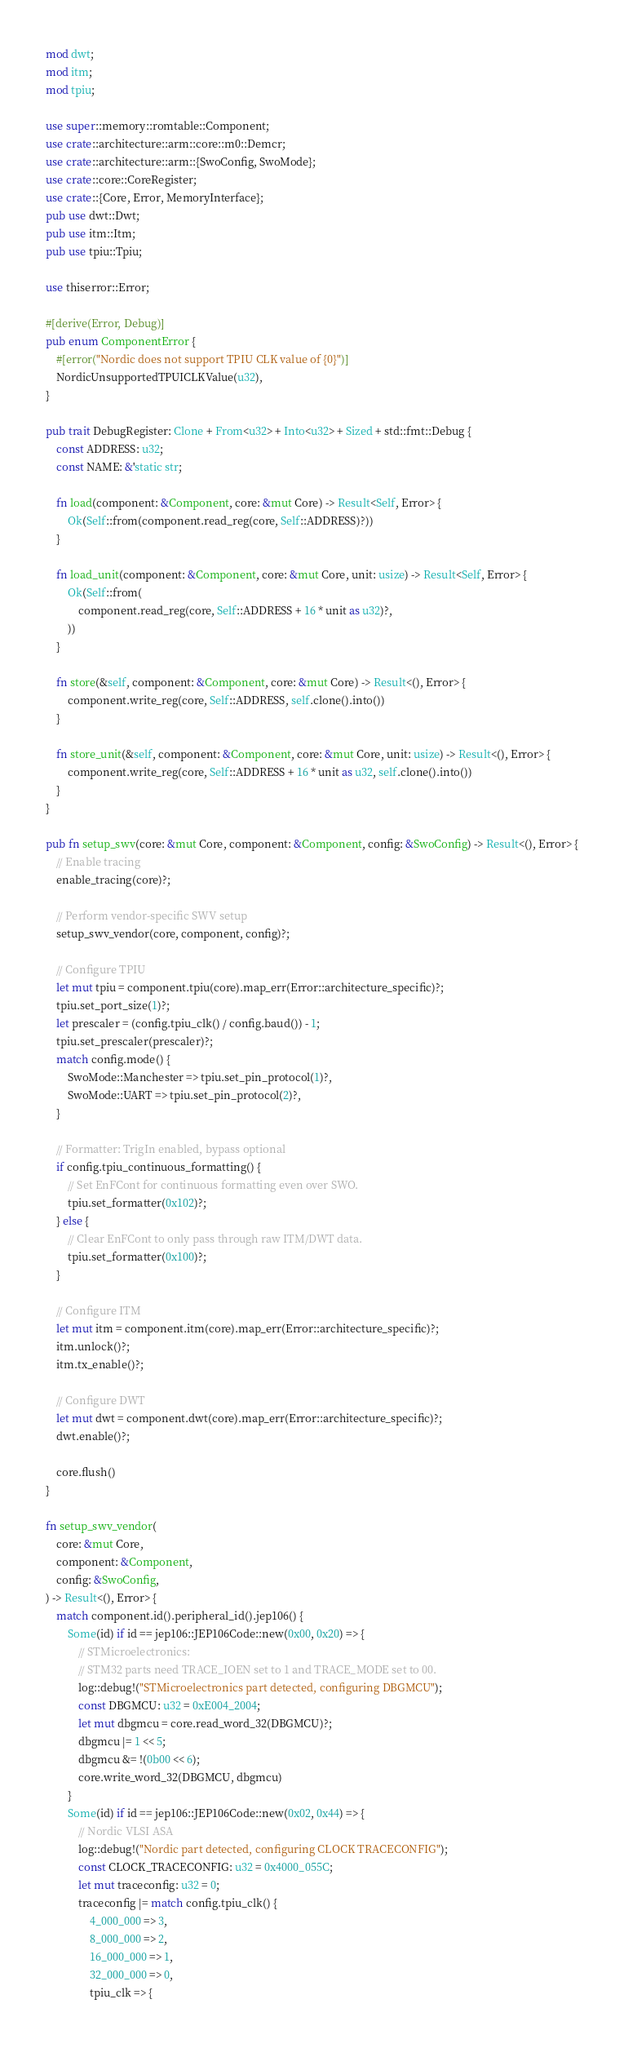Convert code to text. <code><loc_0><loc_0><loc_500><loc_500><_Rust_>mod dwt;
mod itm;
mod tpiu;

use super::memory::romtable::Component;
use crate::architecture::arm::core::m0::Demcr;
use crate::architecture::arm::{SwoConfig, SwoMode};
use crate::core::CoreRegister;
use crate::{Core, Error, MemoryInterface};
pub use dwt::Dwt;
pub use itm::Itm;
pub use tpiu::Tpiu;

use thiserror::Error;

#[derive(Error, Debug)]
pub enum ComponentError {
    #[error("Nordic does not support TPIU CLK value of {0}")]
    NordicUnsupportedTPUICLKValue(u32),
}

pub trait DebugRegister: Clone + From<u32> + Into<u32> + Sized + std::fmt::Debug {
    const ADDRESS: u32;
    const NAME: &'static str;

    fn load(component: &Component, core: &mut Core) -> Result<Self, Error> {
        Ok(Self::from(component.read_reg(core, Self::ADDRESS)?))
    }

    fn load_unit(component: &Component, core: &mut Core, unit: usize) -> Result<Self, Error> {
        Ok(Self::from(
            component.read_reg(core, Self::ADDRESS + 16 * unit as u32)?,
        ))
    }

    fn store(&self, component: &Component, core: &mut Core) -> Result<(), Error> {
        component.write_reg(core, Self::ADDRESS, self.clone().into())
    }

    fn store_unit(&self, component: &Component, core: &mut Core, unit: usize) -> Result<(), Error> {
        component.write_reg(core, Self::ADDRESS + 16 * unit as u32, self.clone().into())
    }
}

pub fn setup_swv(core: &mut Core, component: &Component, config: &SwoConfig) -> Result<(), Error> {
    // Enable tracing
    enable_tracing(core)?;

    // Perform vendor-specific SWV setup
    setup_swv_vendor(core, component, config)?;

    // Configure TPIU
    let mut tpiu = component.tpiu(core).map_err(Error::architecture_specific)?;
    tpiu.set_port_size(1)?;
    let prescaler = (config.tpiu_clk() / config.baud()) - 1;
    tpiu.set_prescaler(prescaler)?;
    match config.mode() {
        SwoMode::Manchester => tpiu.set_pin_protocol(1)?,
        SwoMode::UART => tpiu.set_pin_protocol(2)?,
    }

    // Formatter: TrigIn enabled, bypass optional
    if config.tpiu_continuous_formatting() {
        // Set EnFCont for continuous formatting even over SWO.
        tpiu.set_formatter(0x102)?;
    } else {
        // Clear EnFCont to only pass through raw ITM/DWT data.
        tpiu.set_formatter(0x100)?;
    }

    // Configure ITM
    let mut itm = component.itm(core).map_err(Error::architecture_specific)?;
    itm.unlock()?;
    itm.tx_enable()?;

    // Configure DWT
    let mut dwt = component.dwt(core).map_err(Error::architecture_specific)?;
    dwt.enable()?;

    core.flush()
}

fn setup_swv_vendor(
    core: &mut Core,
    component: &Component,
    config: &SwoConfig,
) -> Result<(), Error> {
    match component.id().peripheral_id().jep106() {
        Some(id) if id == jep106::JEP106Code::new(0x00, 0x20) => {
            // STMicroelectronics:
            // STM32 parts need TRACE_IOEN set to 1 and TRACE_MODE set to 00.
            log::debug!("STMicroelectronics part detected, configuring DBGMCU");
            const DBGMCU: u32 = 0xE004_2004;
            let mut dbgmcu = core.read_word_32(DBGMCU)?;
            dbgmcu |= 1 << 5;
            dbgmcu &= !(0b00 << 6);
            core.write_word_32(DBGMCU, dbgmcu)
        }
        Some(id) if id == jep106::JEP106Code::new(0x02, 0x44) => {
            // Nordic VLSI ASA
            log::debug!("Nordic part detected, configuring CLOCK TRACECONFIG");
            const CLOCK_TRACECONFIG: u32 = 0x4000_055C;
            let mut traceconfig: u32 = 0;
            traceconfig |= match config.tpiu_clk() {
                4_000_000 => 3,
                8_000_000 => 2,
                16_000_000 => 1,
                32_000_000 => 0,
                tpiu_clk => {</code> 